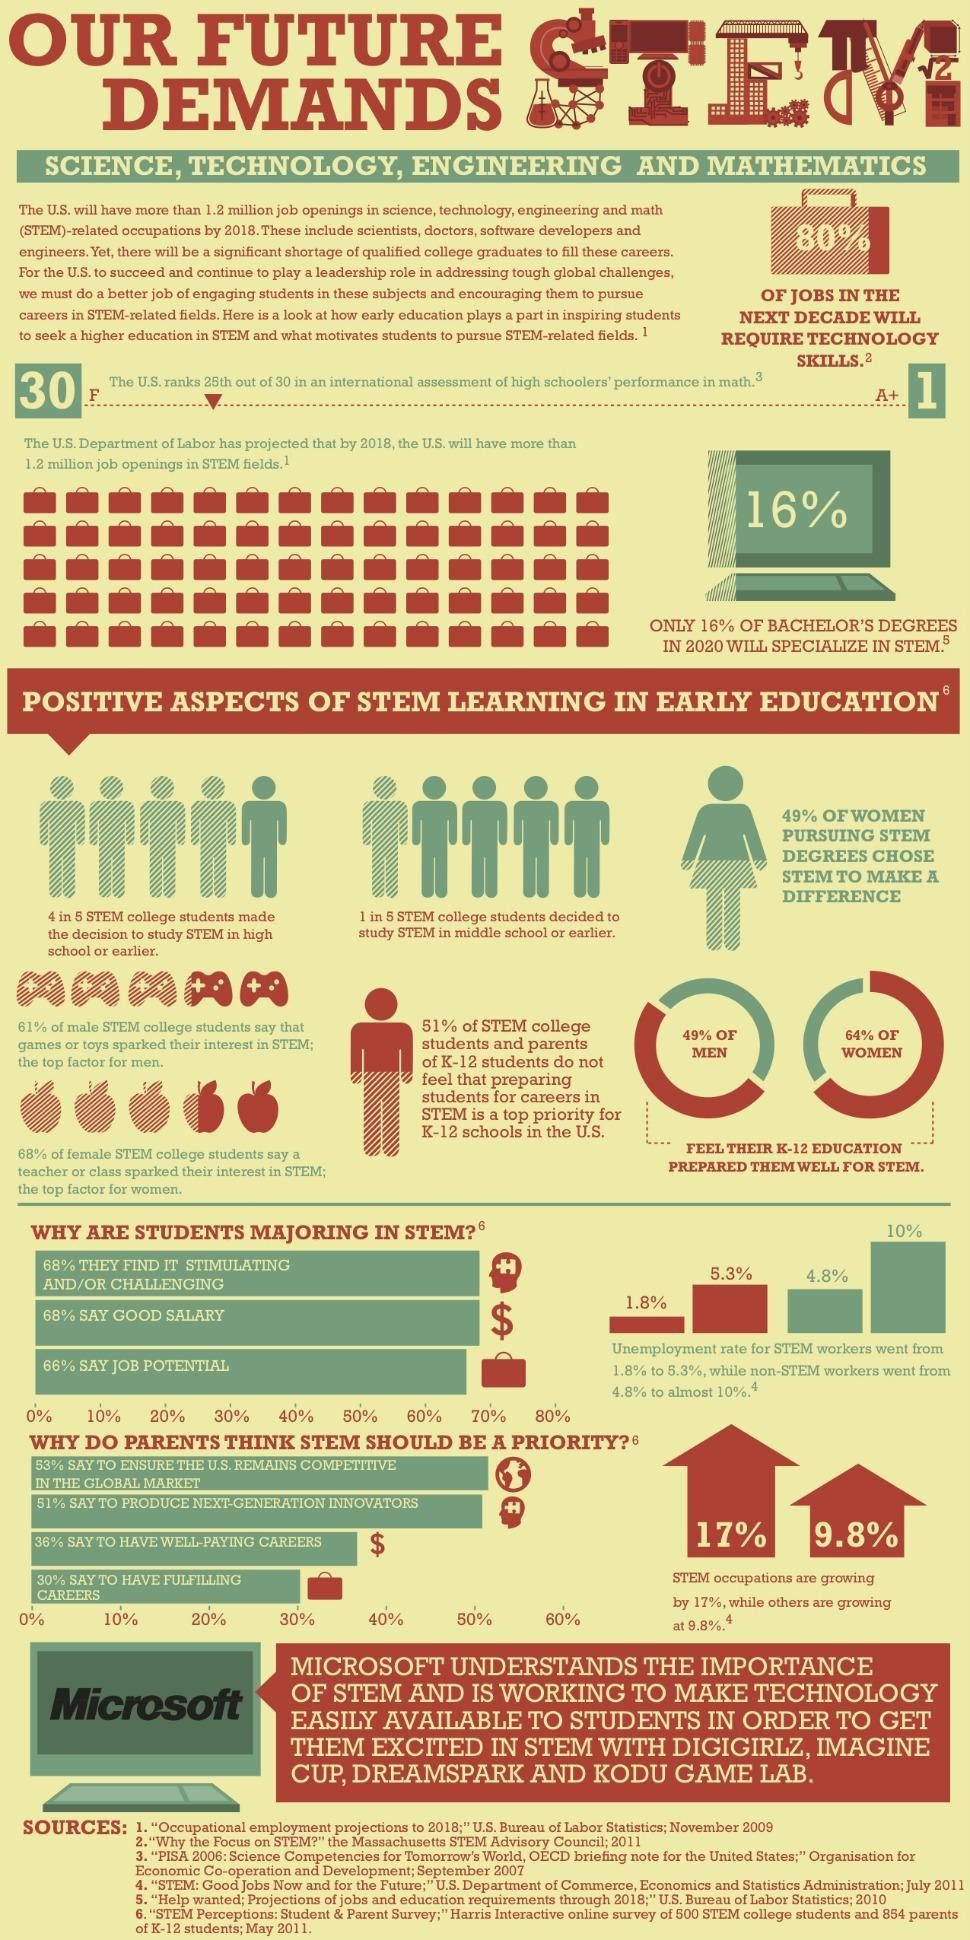What percentage of men feel that K-12 education does not equip them for a career in STEM ?
Answer the question with a short phrase. 51% What is the difference in growth of STEM jobs in comparison to other jobs? 7.2% What percentage of women feel that their K-12 exam will not prepare them for STEM career? 36% 